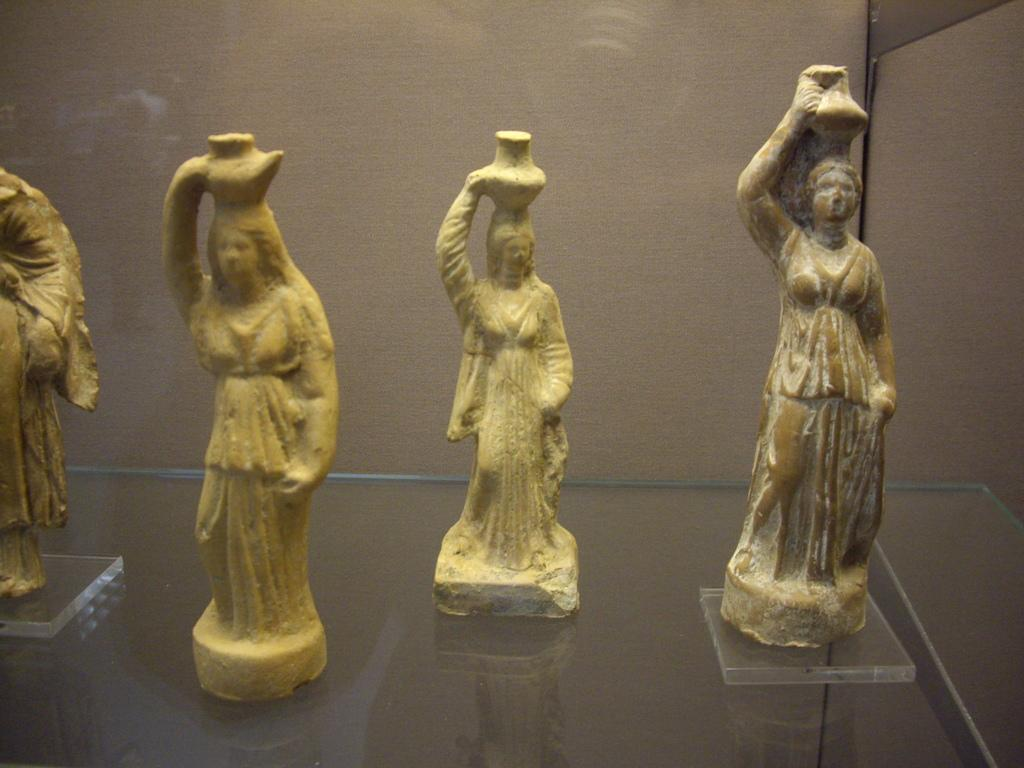What can be seen in the image? There are statues in the image. What is the statues resting on? The statues are on a glass platform. What is visible in the background of the image? There is a wall in the background of the image. What type of creature can be seen causing a shock in the image? There is no creature or shock present in the image; it features statues on a glass platform with a wall in the background. 